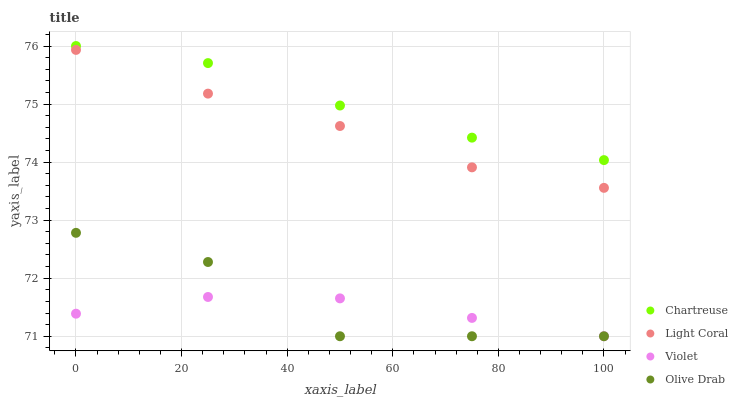Does Violet have the minimum area under the curve?
Answer yes or no. Yes. Does Chartreuse have the maximum area under the curve?
Answer yes or no. Yes. Does Olive Drab have the minimum area under the curve?
Answer yes or no. No. Does Olive Drab have the maximum area under the curve?
Answer yes or no. No. Is Violet the smoothest?
Answer yes or no. Yes. Is Olive Drab the roughest?
Answer yes or no. Yes. Is Chartreuse the smoothest?
Answer yes or no. No. Is Chartreuse the roughest?
Answer yes or no. No. Does Olive Drab have the lowest value?
Answer yes or no. Yes. Does Chartreuse have the lowest value?
Answer yes or no. No. Does Chartreuse have the highest value?
Answer yes or no. Yes. Does Olive Drab have the highest value?
Answer yes or no. No. Is Light Coral less than Chartreuse?
Answer yes or no. Yes. Is Light Coral greater than Olive Drab?
Answer yes or no. Yes. Does Violet intersect Olive Drab?
Answer yes or no. Yes. Is Violet less than Olive Drab?
Answer yes or no. No. Is Violet greater than Olive Drab?
Answer yes or no. No. Does Light Coral intersect Chartreuse?
Answer yes or no. No. 